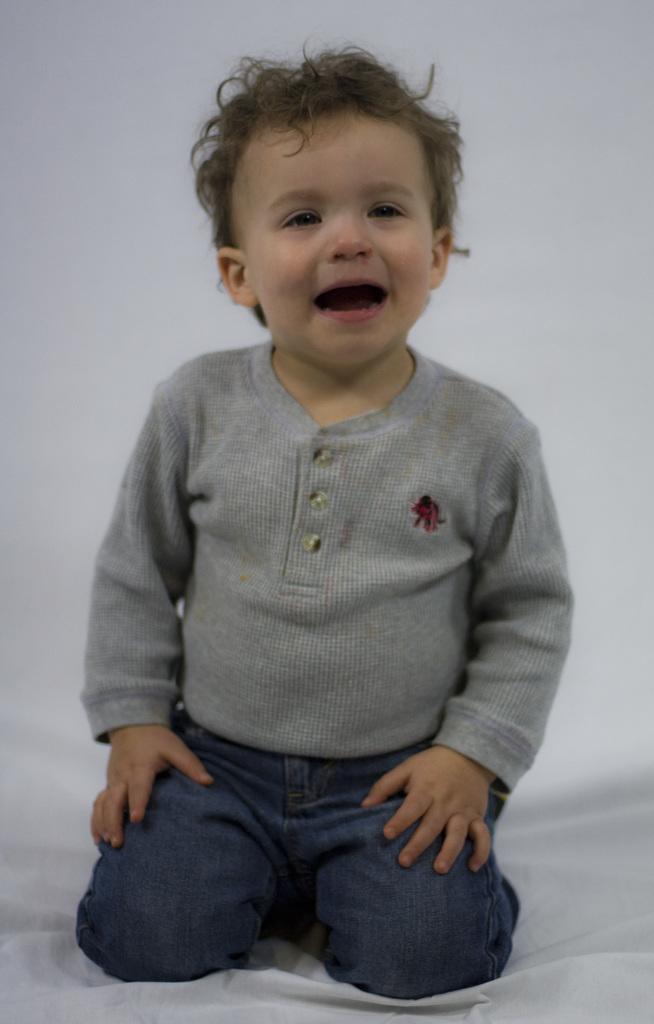Describe this image in one or two sentences. There is one kid sitting on a white color cloth as we can see in the middle of this image. There is a white color wall in the background. 